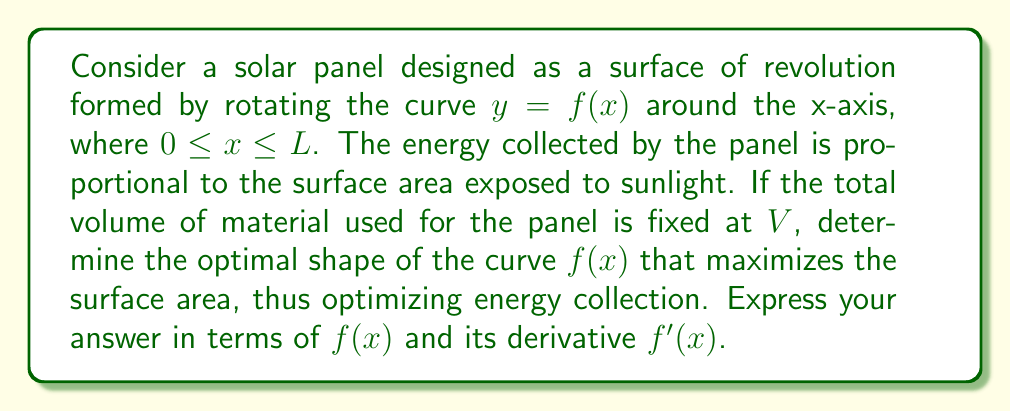Show me your answer to this math problem. To solve this problem, we'll use calculus of variations. Let's approach this step-by-step:

1) The surface area of a surface of revolution is given by:
   $$A = 2\pi \int_0^L f(x) \sqrt{1 + [f'(x)]^2} dx$$

2) The volume of the solid formed by rotating $f(x)$ around the x-axis is:
   $$V = \pi \int_0^L [f(x)]^2 dx$$

3) We want to maximize $A$ subject to the constraint that $V$ is constant. This is a problem for the Euler-Lagrange equation with an isoperimetric constraint.

4) The functional to be maximized is:
   $$F = 2\pi f \sqrt{1 + (f')^2} + \lambda \pi f^2$$
   where $\lambda$ is a Lagrange multiplier.

5) The Euler-Lagrange equation for this problem is:
   $$\frac{\partial F}{\partial f} - \frac{d}{dx}\left(\frac{\partial F}{\partial f'}\right) = 0$$

6) Calculating the partial derivatives:
   $$\frac{\partial F}{\partial f} = 2\pi \sqrt{1 + (f')^2} + 2\lambda \pi f$$
   $$\frac{\partial F}{\partial f'} = \frac{2\pi f (f')}{\sqrt{1 + (f')^2}}$$

7) Substituting into the Euler-Lagrange equation:
   $$2\pi \sqrt{1 + (f')^2} + 2\lambda \pi f - \frac{d}{dx}\left(\frac{2\pi f (f')}{\sqrt{1 + (f')^2}}\right) = 0$$

8) After simplification, this leads to the differential equation:
   $$\frac{1}{f\sqrt{1 + (f')^2}} = C$$
   where $C$ is a constant.

9) The solution to this equation is a catenary curve:
   $$f(x) = a \cosh(\frac{x-b}{a})$$
   where $a$ and $b$ are constants determined by the boundary conditions and the volume constraint.
Answer: $f(x) = a \cosh(\frac{x-b}{a})$ 